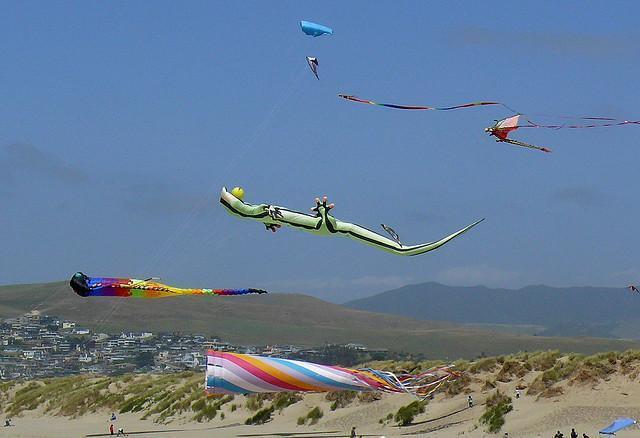How many kites are in the sky?
Give a very brief answer. 6. How many kites can be seen?
Give a very brief answer. 3. How many baby sheep are there?
Give a very brief answer. 0. 